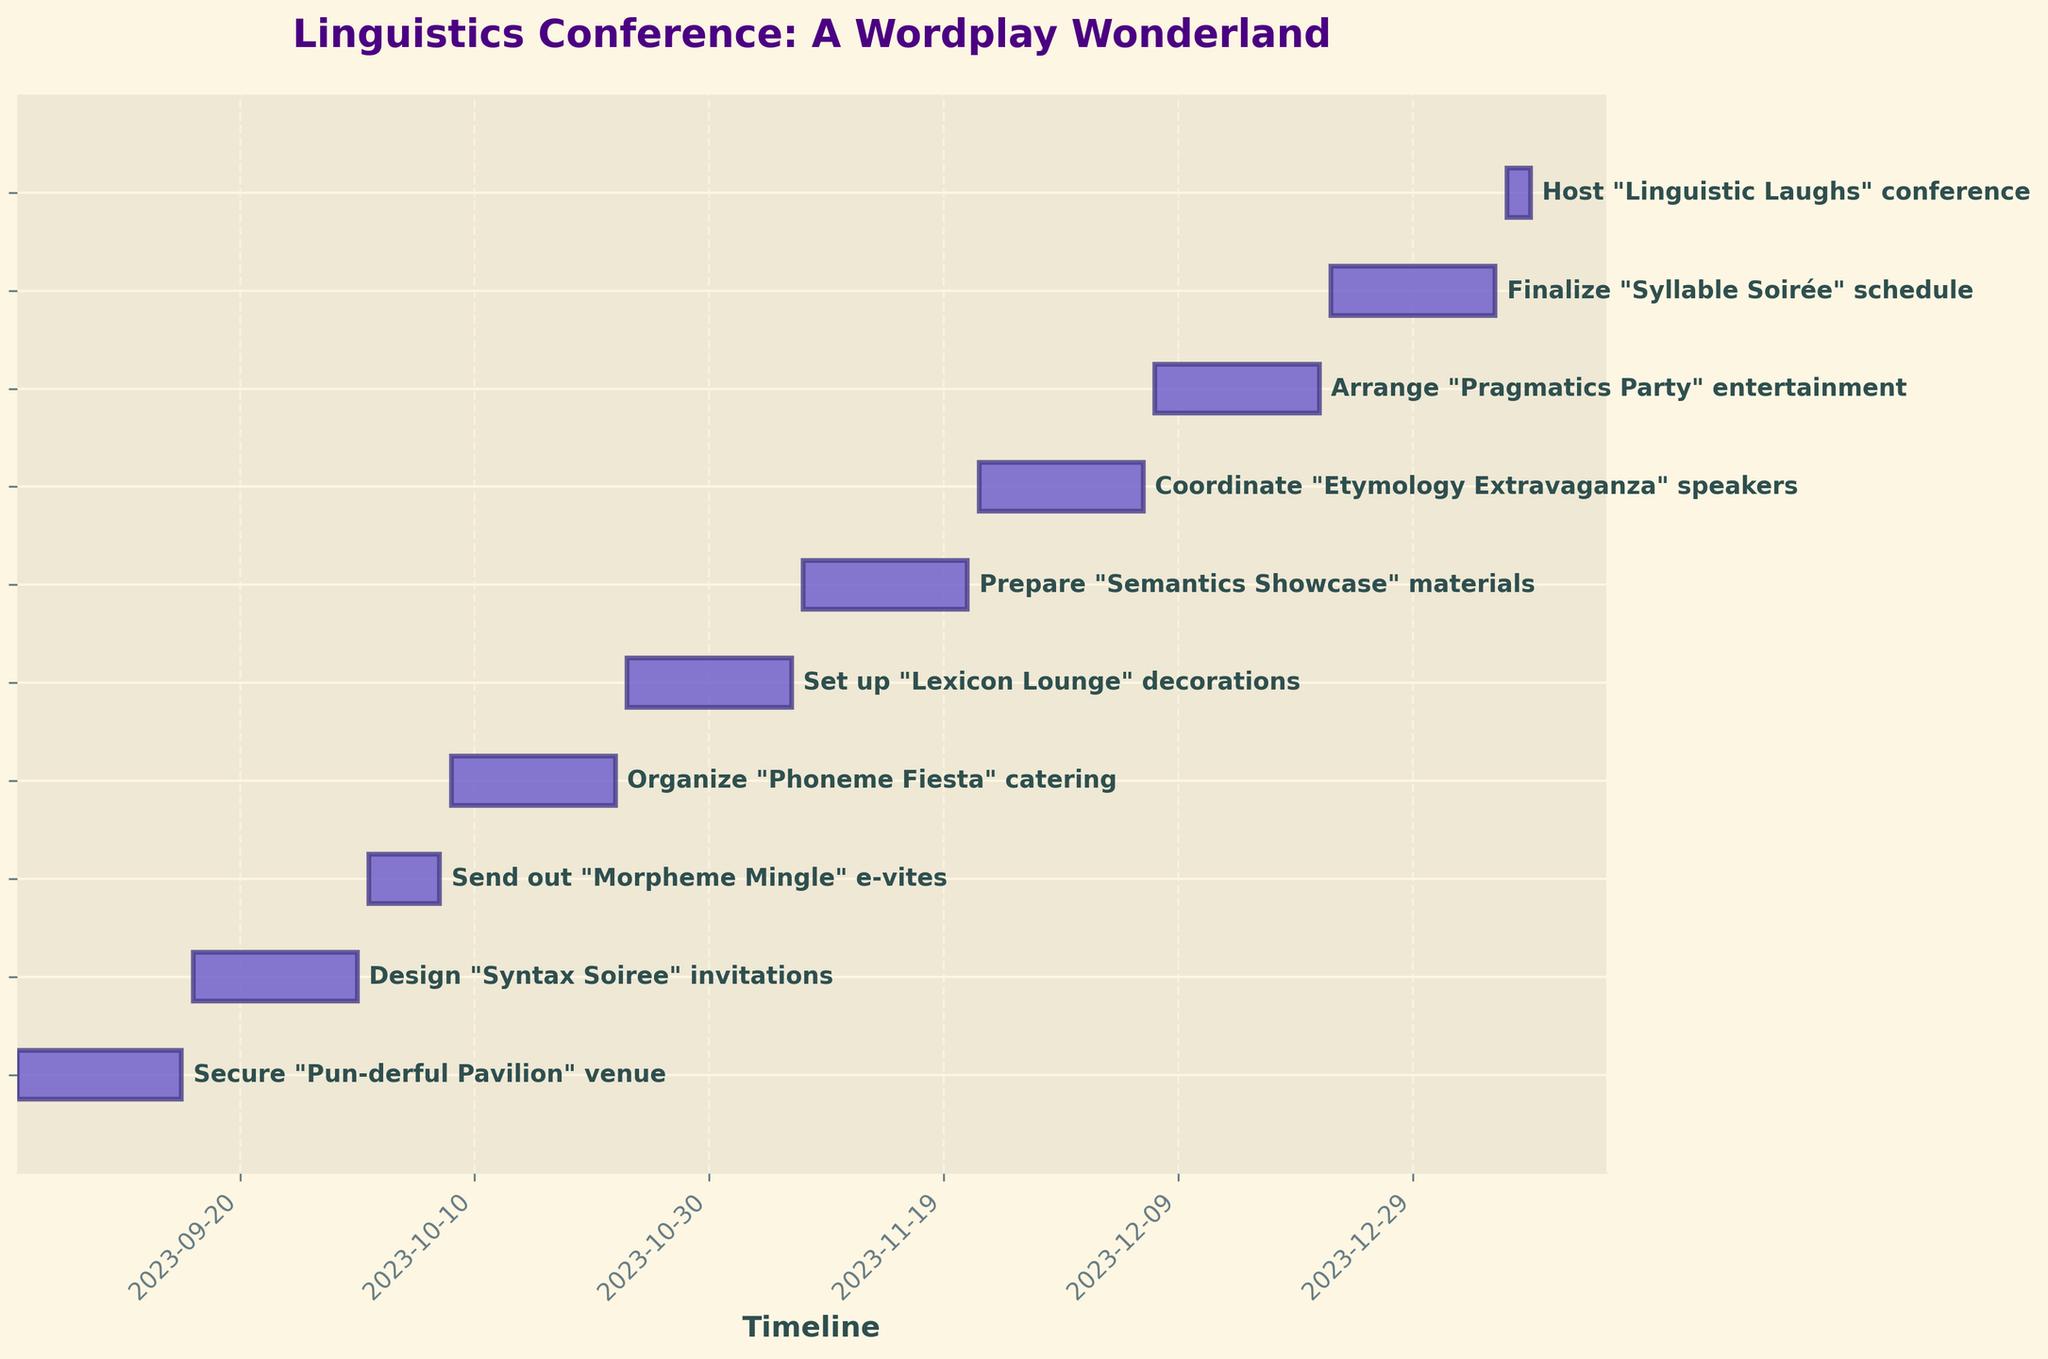What is the title of the Gantt chart? The title is located at the top of the chart and is usually descriptive of the overall content. In this chart, it reads: "Linguistics Conference: A Wordplay Wonderland".
Answer: Linguistics Conference: A Wordplay Wonderland What is the color of the bars representing the tasks? The bars representing the tasks are mainly shaded in a distinctive hue. In this chart, the bars are purple with a slightly darker edge.
Answer: Purple How many tasks are outlined in this chart? By counting the number of bars (tasks) on the vertical axis, we find there are exactly 10 bars, each corresponding to a different task.
Answer: 10 What is the start date for setting up the "Lexicon Lounge" decorations? Locate the task labeled "Set up 'Lexicon Lounge' decorations." Look horizontally to find the start of its bar which aligns with its start date listed at the bottom.
Answer: 2023-10-23 Which task has the shortest duration? Identify the task with the smallest horizontal bar. The bar labeled "Host 'Linguistic Laughs' conference" is the shortest, spanning from 2024-01-06 to 2024-01-08.
Answer: Host 'Linguistic Laughs' conference Did any tasks overlap in their time frames? Check if any two bars start and end within the same period. For instance, "Send out 'Morpheme Mingle' e-vites" and "Organize 'Phoneme Fiesta' catering" overlap.
Answer: Yes What is the total duration covered by the entire project from the start of the first task to the end of the last task? Identify the start date of the first task ("Secure 'Pun-derful Pavilion' venue" on 2023-09-01) and the end date of the last task ("Host 'Linguistic Laughs' conference" on 2024-01-08). The total duration is from 2023-09-01 to 2024-01-08.
Answer: From 2023-09-01 to 2024-01-08 What task directly follows organizing the "Phoneme Fiesta" catering? Observe the timeline sequence. The task directly after "Organize 'Phoneme Fiesta' catering" is "Set up 'Lexicon Lounge' decorations".
Answer: Set up 'Lexicon Lounge' decorations What is the combined duration of "Prepare 'Semantics Showcase' materials" and "Coordinate 'Etymology Extravaganza' speakers"? Note the durations of both tasks (15 days each) from the task list. Adding them together gives 15 + 15 = 30 days.
Answer: 30 days 